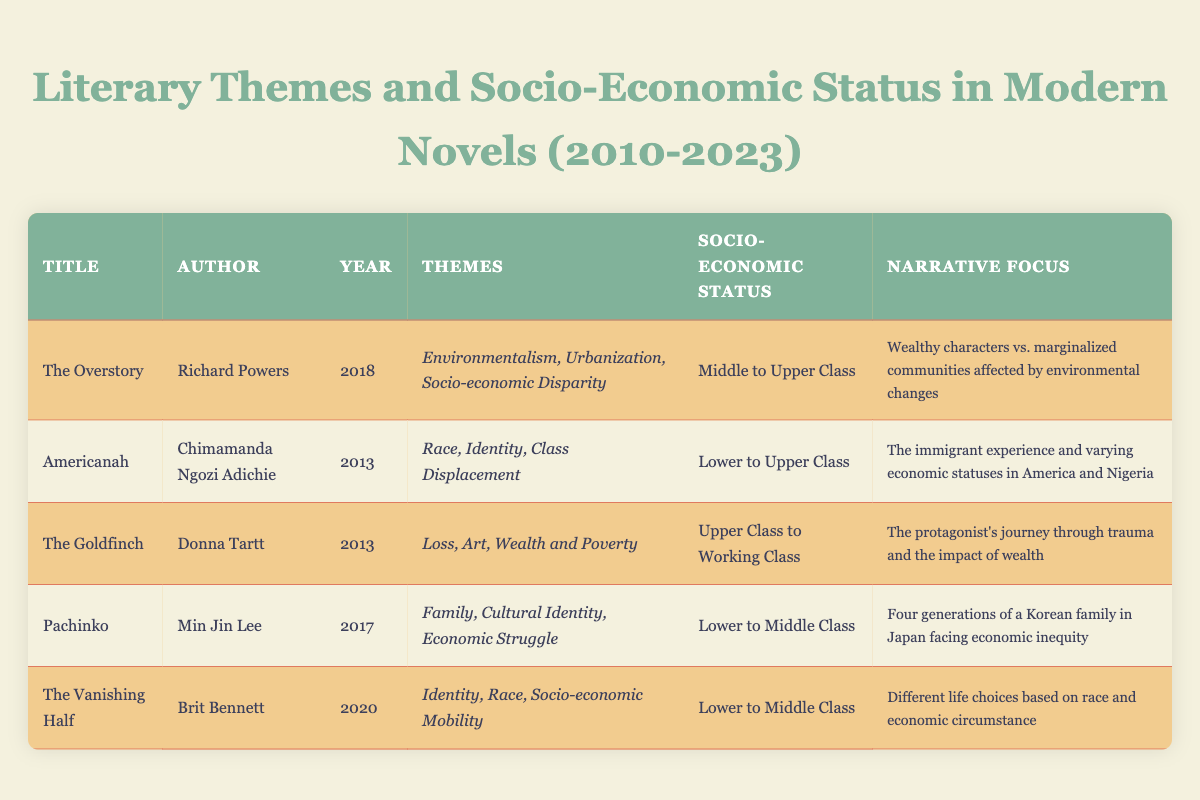What are the themes of "The Goldfinch"? The table shows that the themes of "The Goldfinch" by Donna Tartt are Loss, Art, Wealth and Poverty. These themes are specifically listed in the 'Themes' column of the table.
Answer: Loss, Art, Wealth and Poverty Which novel was published in 2020? According to the table, "The Vanishing Half" by Brit Bennett is listed under the publication year 2020, found in the 'Year' column.
Answer: The Vanishing Half Is "Pachinko" focused on Upper Class socio-economic status? The table indicates that "Pachinko" by Min Jin Lee has a socio-economic status labeled as Lower to Middle Class, which means it does not focus on Upper Class.
Answer: No How many novels in the table focus on socio-economic disparity themes? The table lists several novels with different themes. Checking through the 'Themes' column, "The Overstory" and "Americanah" are identified as having socio-economic disparity themes. Therefore, there are two novels that focus on this theme.
Answer: 2 What is the narrative focus of "Americanah"? The table shows that the narrative focus of "Americanah" by Chimamanda Ngozi Adichie is about "The immigrant experience and varying economic statuses in America and Nigeria," as indicated in the 'Narrative Focus' column.
Answer: The immigrant experience and varying economic statuses in America and Nigeria Which author has written more than one novel in this table? Reviewing the table, it appears only individual authors are listed without repetition, so there are no authors with more than one novel in this data.
Answer: No Which socio-economic status has the highest representation in the table? By examining the socio-economic status column, we can count the frequency of categories: Middle to Upper Class (1), Lower to Upper Class (1), Upper Class to Working Class (1), Lower to Middle Class (2). Lower to Middle Class has the highest representation with 2 entries.
Answer: Lower to Middle Class What are the common themes related to socio-economic status in novels published from 2010 to 2023? By analyzing the themes provided in the table, common themes include Economic Struggle, Socio-economic Disparity, and Class Displacement, which are mentioned across different novels. Each novel's themes reflect how socio-economic status influences narrative focuses and character experiences.
Answer: Economic Struggle, Socio-economic Disparity, Class Displacement What publication year is associated with "The Overstory"? The table specifies that "The Overstory" by Richard Powers was published in the year 2018, which is indicated in the 'Year' column.
Answer: 2018 